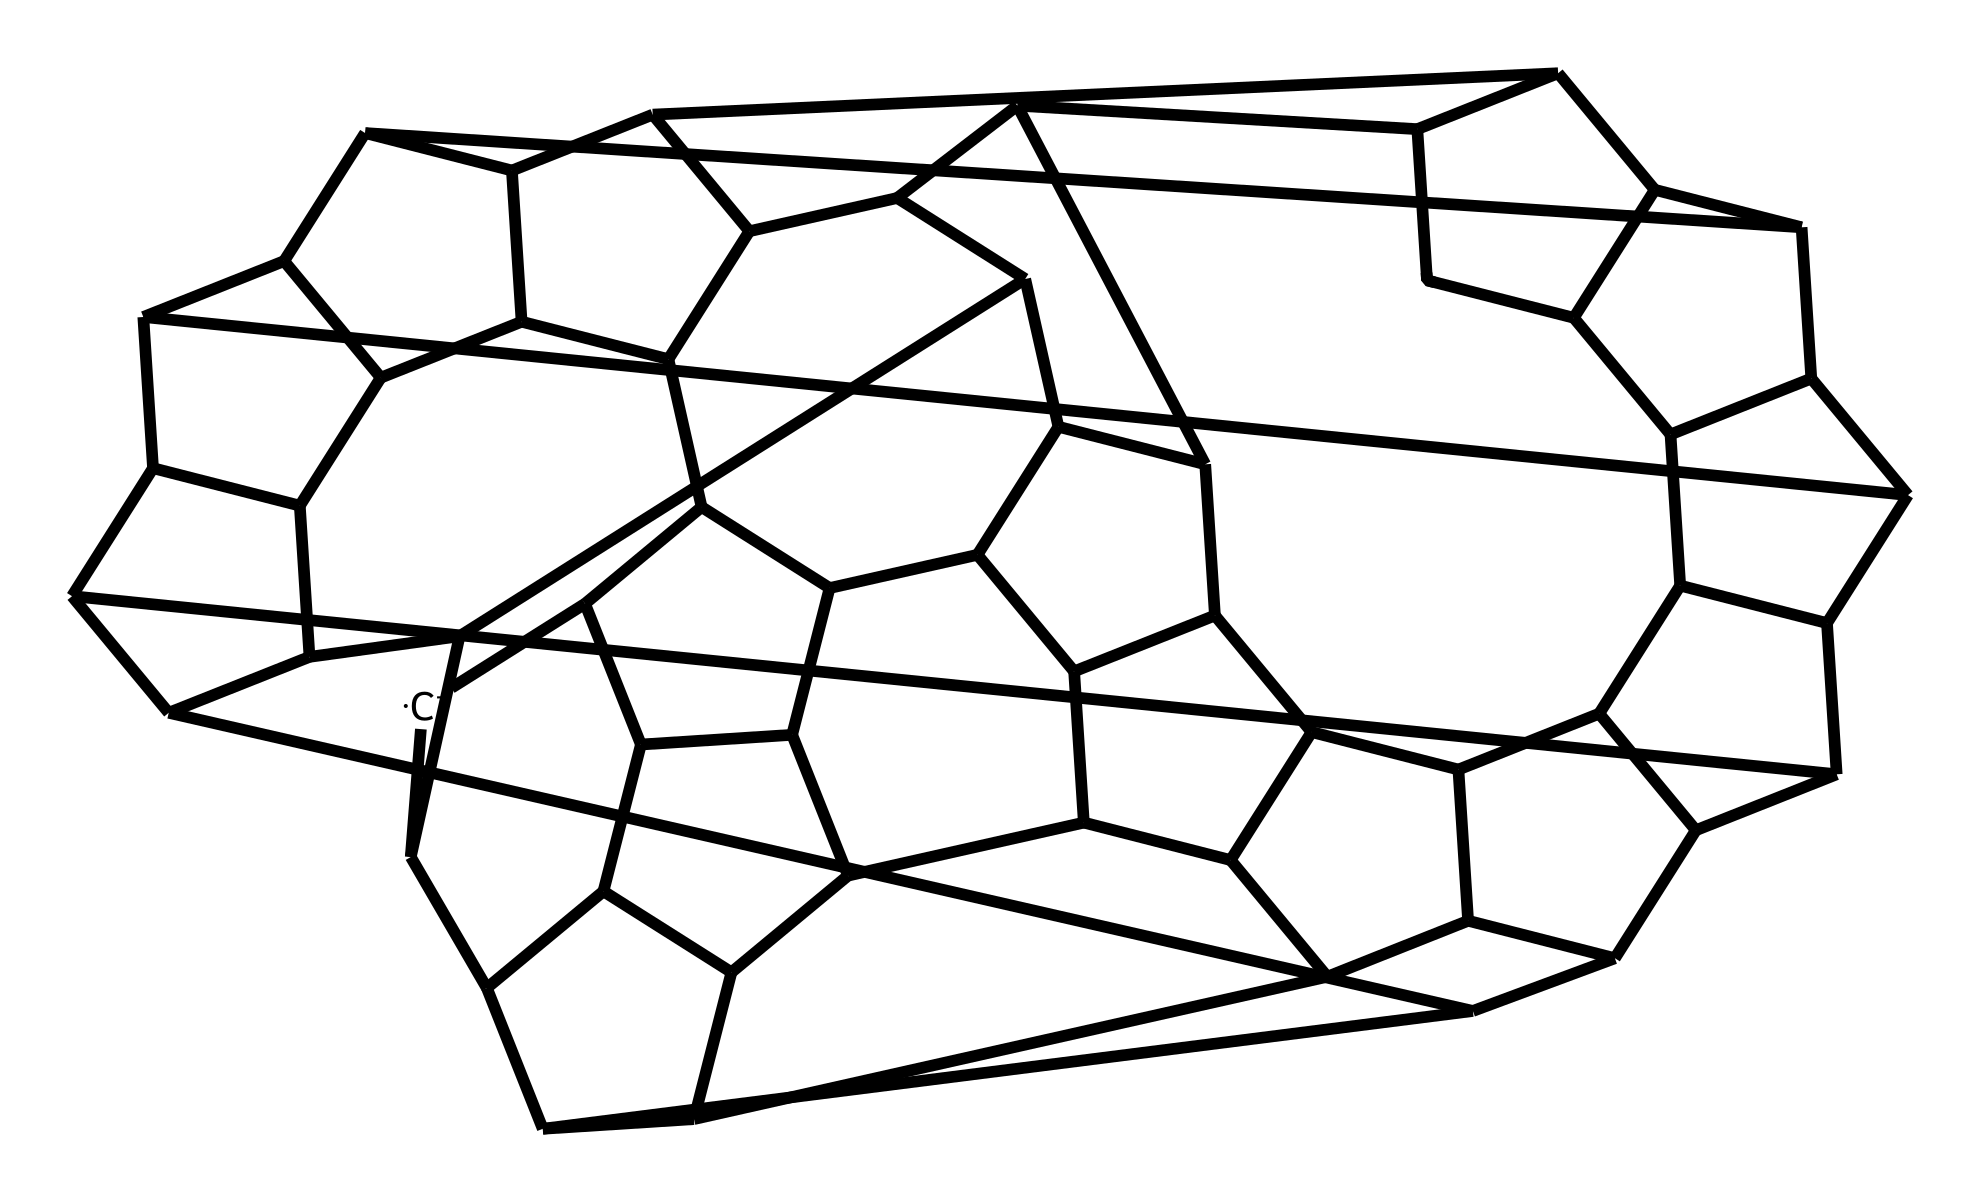What is the total number of carbon atoms in this fulleride? By analyzing the SMILES representation, we can count the number of "C" symbols present. Each "C" corresponds to a carbon atom, and there are frequently appearances of the letter indicating multiple atoms in branching structures. Counting them results in a total of 60 carbon atoms.
Answer: 60 How many double bonds are there in this fulleride structure? In the fulleride representation, we can look for the presence of double bonds typically indicated in chemical structures, but in this SMILES, there are no apparent double bond symbols. Therefore, upon thorough examination, it becomes clear that there are no double bonds present.
Answer: 0 What type of ions do fullerides typically form in a corrosion-resistant coating? Fullerides can form anions typically consisting of an even number of carbon atoms. Given the established structure of fullerides, they frequently exist as C60-based anions due to their stability and tendency to donate electrons, which enhances corrosion resistance.
Answer: anions Is this fulleride capable of forming a closed-shell structure? The representation shows a complex interlinking of carbon atoms which suggests that this fulleride has a spherical structure. Spherical fullerides, particularly C60, are known to exhibit closed-shell characteristics due to their electron configuration, making them stable and effective in coatings.
Answer: yes Which property of fullerides contributes to their effectiveness in corrosion-resistant coatings? The unique electron-rich nature of fullerides, resulting from the specific arrangement of carbon atoms and their capacity to delocalize electrons, enhances their ability to impede corrosion processes on metal surfaces. Understanding this electronic property reveals why they are beneficial in protective coatings.
Answer: electron-rich 